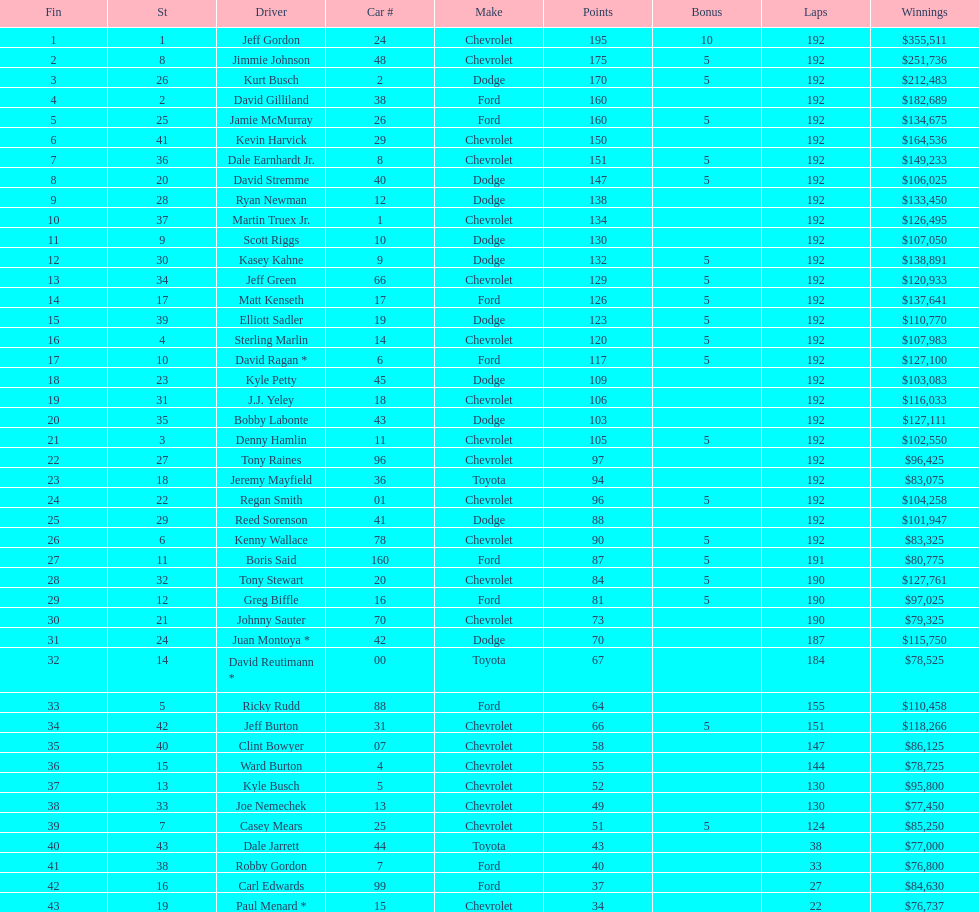Who is first in number of winnings on this list? Jeff Gordon. 